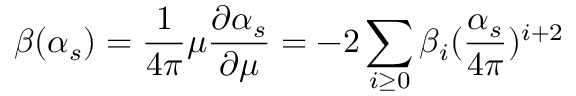<formula> <loc_0><loc_0><loc_500><loc_500>\beta ( \alpha _ { s } ) = \frac { 1 } { 4 \pi } \mu \frac { \partial \alpha _ { s } } { \partial \mu } = - 2 \sum _ { i \geq 0 } \beta _ { i } ( \frac { \alpha _ { s } } { 4 \pi } ) ^ { i + 2 }</formula> 